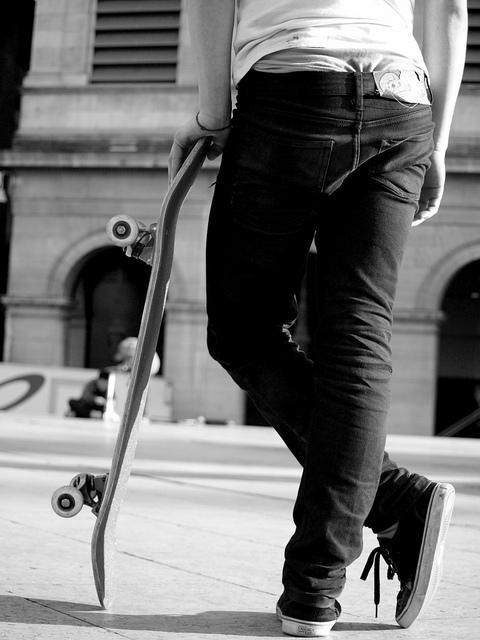What can the object the person is leaning on be used for?

Choices:
A) running
B) transportation
C) swimming
D) flying transportation 